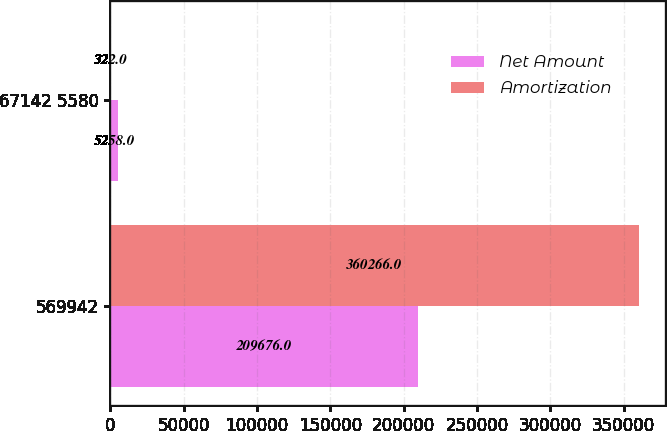Convert chart. <chart><loc_0><loc_0><loc_500><loc_500><stacked_bar_chart><ecel><fcel>569942<fcel>67142 5580<nl><fcel>Net Amount<fcel>209676<fcel>5258<nl><fcel>Amortization<fcel>360266<fcel>322<nl></chart> 